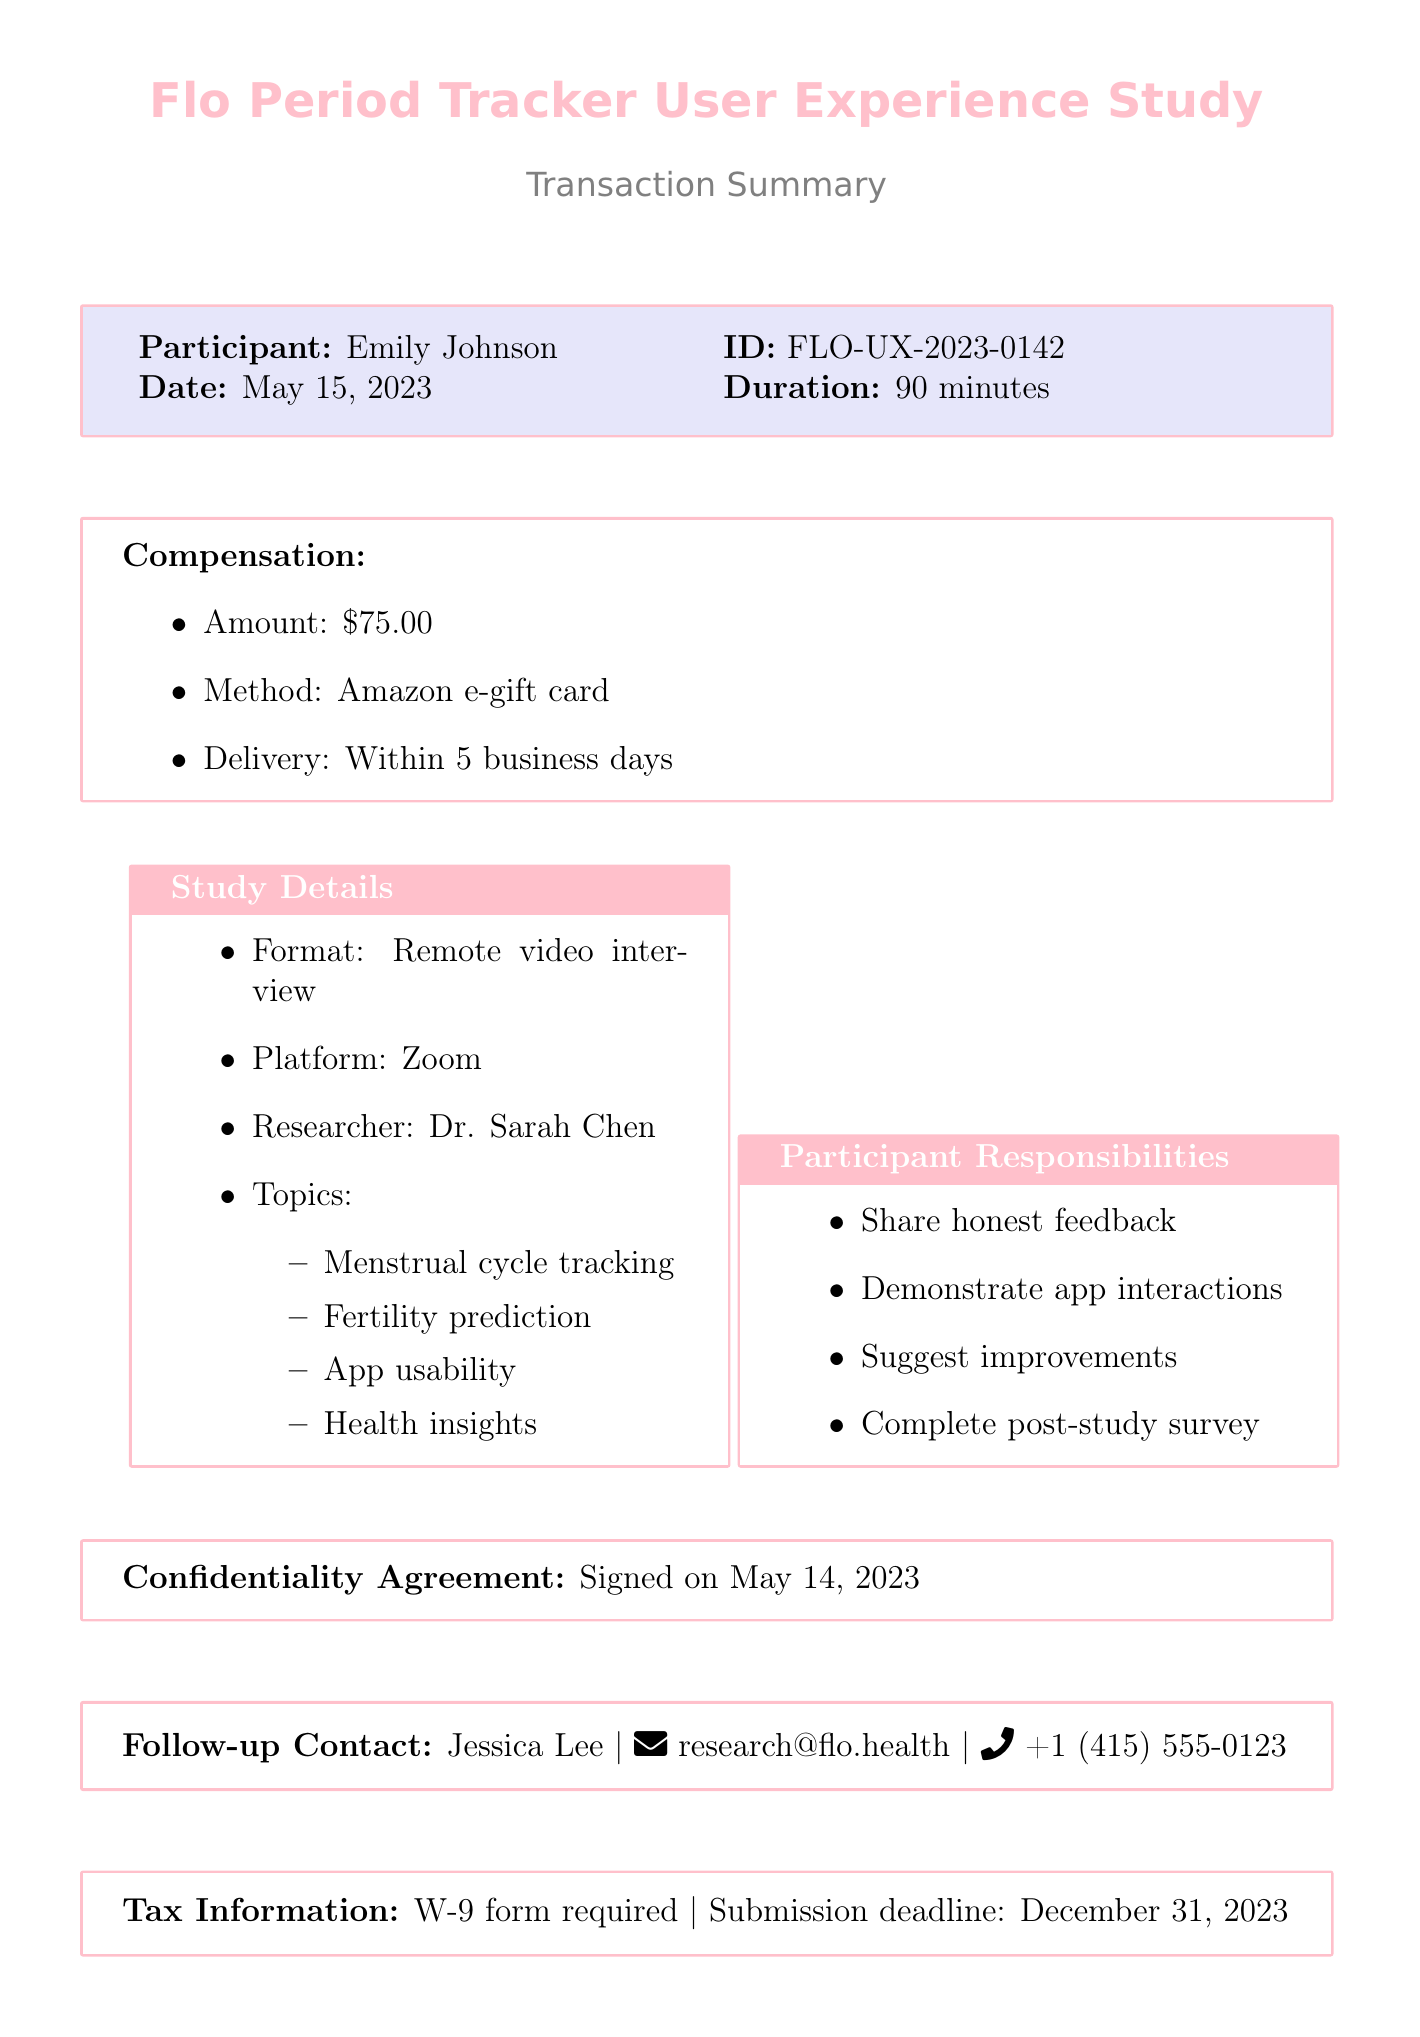What is the study name? The study name is listed at the top of the document, which is "Flo Period Tracker User Experience Study."
Answer: Flo Period Tracker User Experience Study Who is the participant? The document states the participant's name as "Emily Johnson."
Answer: Emily Johnson What is the amount of compensation? The compensation amount is explicitly mentioned in the compensation section of the document as "$75.00."
Answer: $75.00 How long is the study duration? The study duration is specified in the participant details section, showing "90 minutes."
Answer: 90 minutes What delivery timeframe is stated for the compensation? The delivery timeframe for the compensation is included in the compensation details, indicating "Within 5 business days."
Answer: Within 5 business days What is the format of the study? The format of the study is described in the study details section, which states it is a "Remote video interview."
Answer: Remote video interview Who will participants contact for follow-up? The document specifies the follow-up contact person as "Jessica Lee."
Answer: Jessica Lee What tax form is required? The required tax form is mentioned in the tax information section as "W-9."
Answer: W-9 